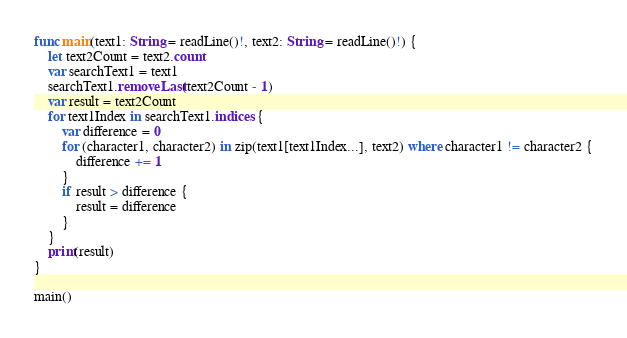Convert code to text. <code><loc_0><loc_0><loc_500><loc_500><_Swift_>func main(text1: String = readLine()!, text2: String = readLine()!) {
    let text2Count = text2.count
    var searchText1 = text1
    searchText1.removeLast(text2Count - 1)
    var result = text2Count
    for text1Index in searchText1.indices {
        var difference = 0
        for (character1, character2) in zip(text1[text1Index...], text2) where character1 != character2 {
            difference += 1
        }
        if result > difference {
            result = difference
        }
    }
    print(result)
}

main()</code> 